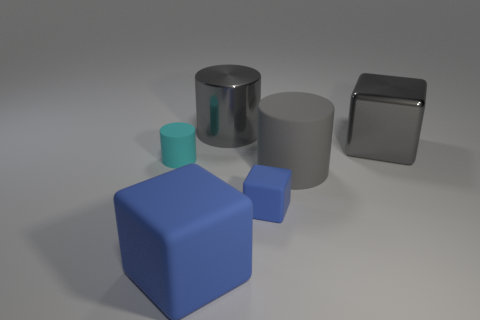Are there more blue things that are to the left of the large matte cube than gray metallic spheres?
Provide a short and direct response. No. Do the cyan matte cylinder and the gray rubber cylinder have the same size?
Your answer should be very brief. No. There is a large cylinder that is the same material as the large blue cube; what color is it?
Ensure brevity in your answer.  Gray. There is a big rubber object that is the same color as the shiny cylinder; what is its shape?
Your answer should be very brief. Cylinder. Are there an equal number of small cyan rubber objects to the right of the tiny blue rubber block and gray rubber objects that are in front of the big gray rubber cylinder?
Provide a short and direct response. Yes. What shape is the large gray metallic object to the left of the gray thing in front of the small rubber cylinder?
Keep it short and to the point. Cylinder. What is the material of the gray object that is the same shape as the large blue object?
Offer a terse response. Metal. What color is the shiny object that is the same size as the gray metallic cube?
Your answer should be compact. Gray. Are there the same number of big metal cubes that are in front of the big blue block and large purple shiny cylinders?
Give a very brief answer. Yes. There is a cylinder to the left of the big cube on the left side of the big gray metal cylinder; what is its color?
Provide a short and direct response. Cyan. 